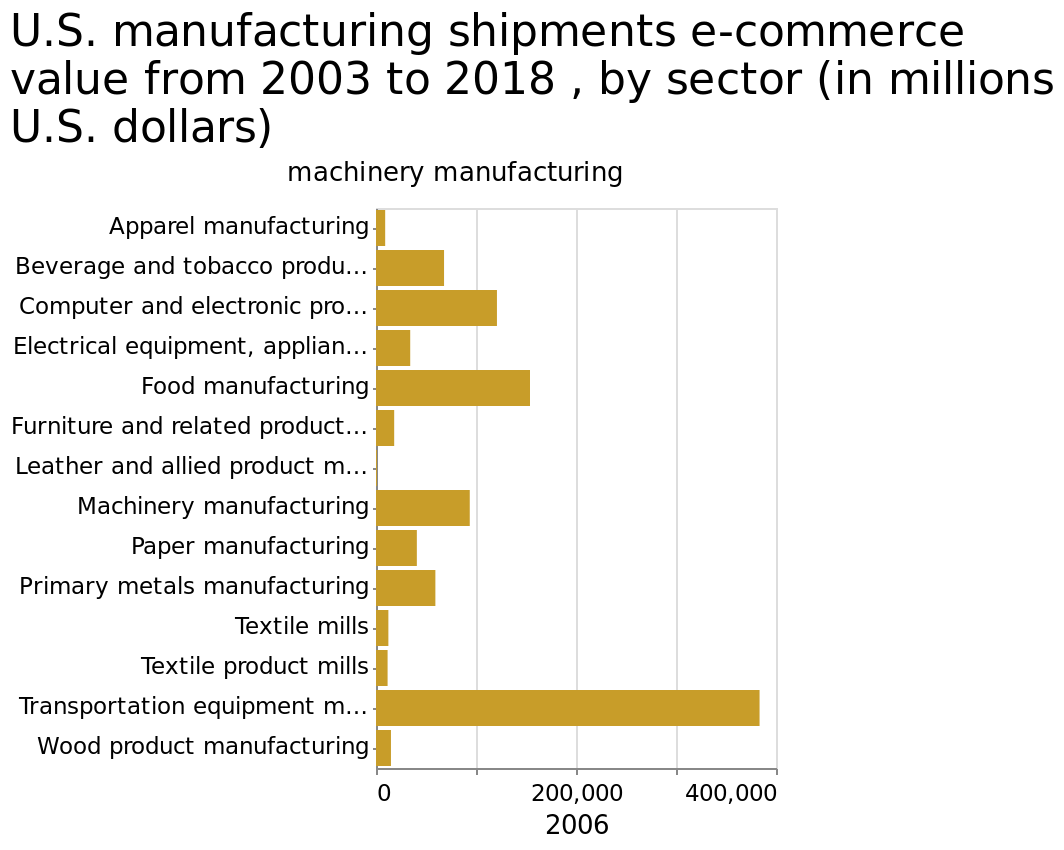<image>
What was the most valuable type of machinery manufacturing in the US in 2006? Transport equipment. Offer a thorough analysis of the image. Transport equipment was the most valuable type of machinery manufacturing in the US in 2006. 